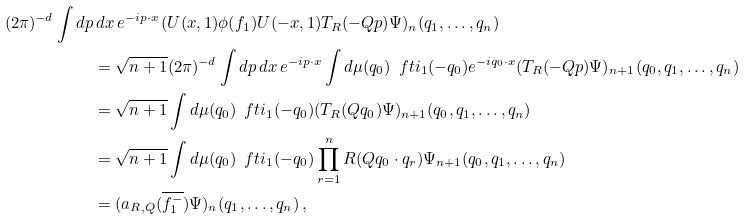<formula> <loc_0><loc_0><loc_500><loc_500>( 2 \pi ) ^ { - d } \int d p & \, d x \, e ^ { - i p \cdot x } \, ( U ( x , 1 ) \phi ( f _ { 1 } ) U ( - x , 1 ) T _ { R } ( - Q p ) \Psi ) _ { n } ( q _ { 1 } , \dots , q _ { n } ) \\ & = \sqrt { n + 1 } ( 2 \pi ) ^ { - d } \int d p \, d x \, e ^ { - i p \cdot x } \int d \mu ( q _ { 0 } ) \, \ f t i _ { 1 } ( - q _ { 0 } ) e ^ { - i q _ { 0 } \cdot x } ( T _ { R } ( - Q p ) \Psi ) _ { n + 1 } ( q _ { 0 } , q _ { 1 } , \dots , q _ { n } ) \\ & = \sqrt { n + 1 } \int d \mu ( q _ { 0 } ) \, \ f t i _ { 1 } ( - q _ { 0 } ) ( T _ { R } ( Q q _ { 0 } ) \Psi ) _ { n + 1 } ( q _ { 0 } , q _ { 1 } , \dots , q _ { n } ) \\ & = \sqrt { n + 1 } \int d \mu ( q _ { 0 } ) \, \ f t i _ { 1 } ( - q _ { 0 } ) \prod _ { r = 1 } ^ { n } R ( Q q _ { 0 } \cdot q _ { r } ) \Psi _ { n + 1 } ( q _ { 0 } , q _ { 1 } , \dots , q _ { n } ) \\ & = ( a _ { R , Q } ( \overline { f _ { 1 } ^ { - } } ) \Psi ) _ { n } ( q _ { 1 } , \dots , q _ { n } ) \, ,</formula> 